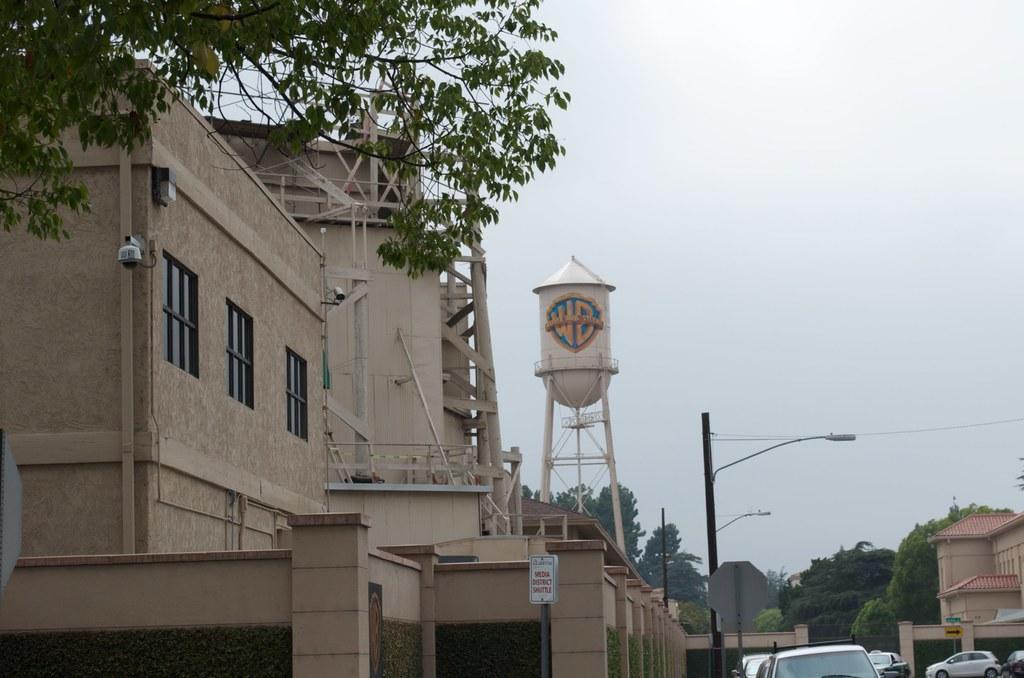In one or two sentences, can you explain what this image depicts? In this image, on the right side, we can see some cars, buildings, trees. In the middle of the image, we can see street light, electric pole, electric wires. On the left side, we can see some buildings, camera, trees, tower. At the top, we can see a sky. 